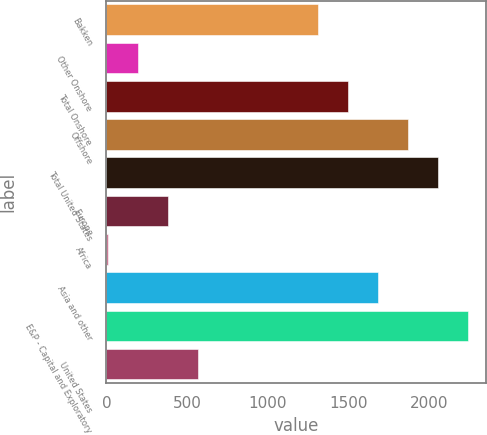<chart> <loc_0><loc_0><loc_500><loc_500><bar_chart><fcel>Bakken<fcel>Other Onshore<fcel>Total Onshore<fcel>Offshore<fcel>Total United States<fcel>Europe<fcel>Africa<fcel>Asia and other<fcel>E&P - Capital and Exploratory<fcel>United States<nl><fcel>1312.7<fcel>196.1<fcel>1498.8<fcel>1871<fcel>2057.1<fcel>382.2<fcel>10<fcel>1684.9<fcel>2243.2<fcel>568.3<nl></chart> 